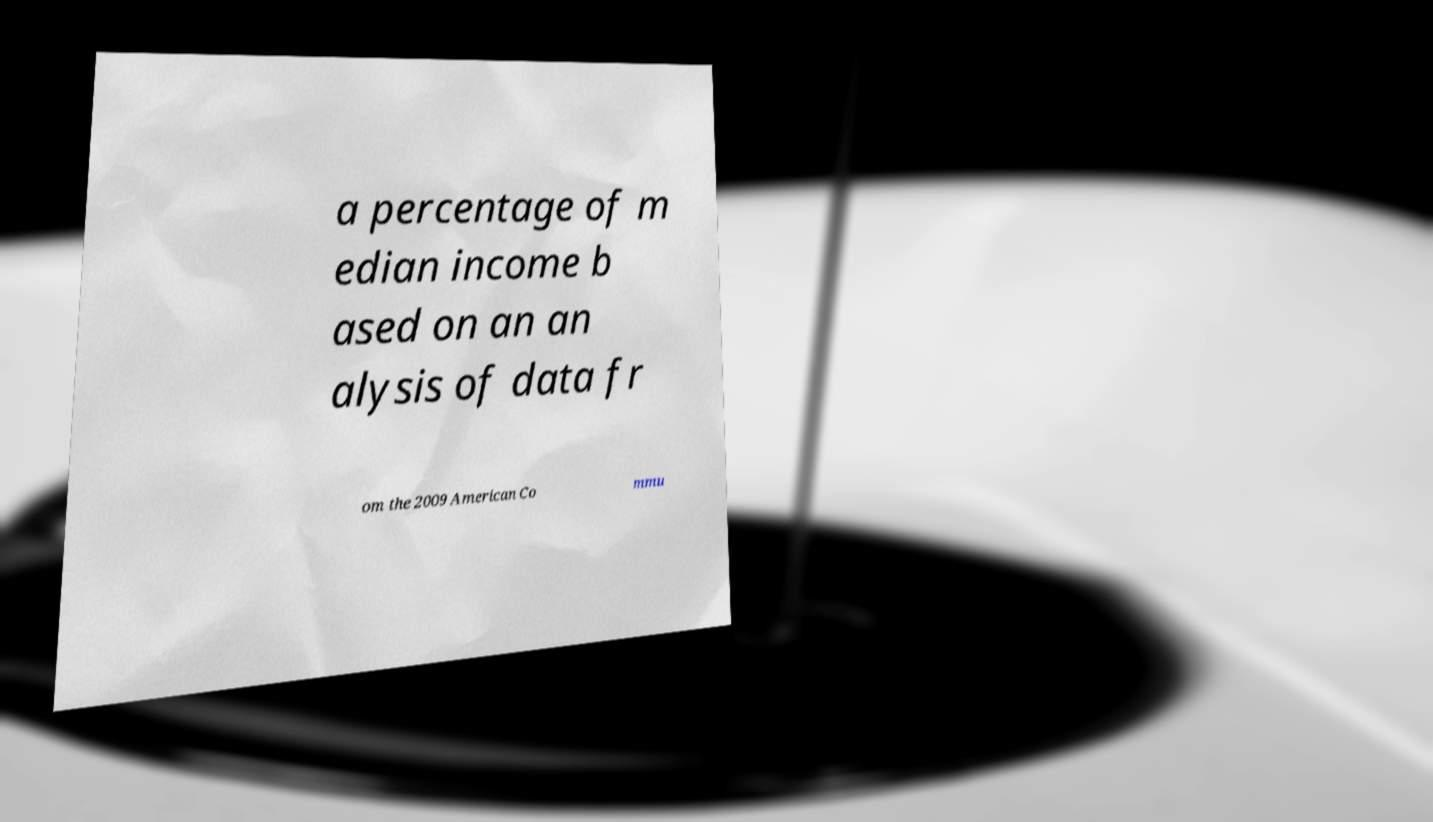Could you extract and type out the text from this image? a percentage of m edian income b ased on an an alysis of data fr om the 2009 American Co mmu 